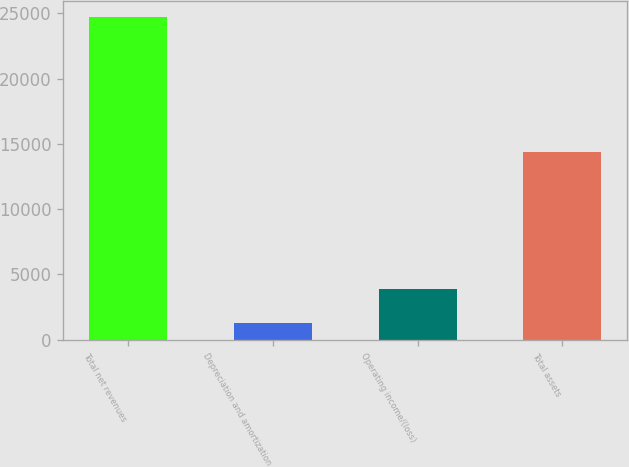Convert chart. <chart><loc_0><loc_0><loc_500><loc_500><bar_chart><fcel>Total net revenues<fcel>Depreciation and amortization<fcel>Operating income/(loss)<fcel>Total assets<nl><fcel>24719.5<fcel>1247<fcel>3883.3<fcel>14365.6<nl></chart> 